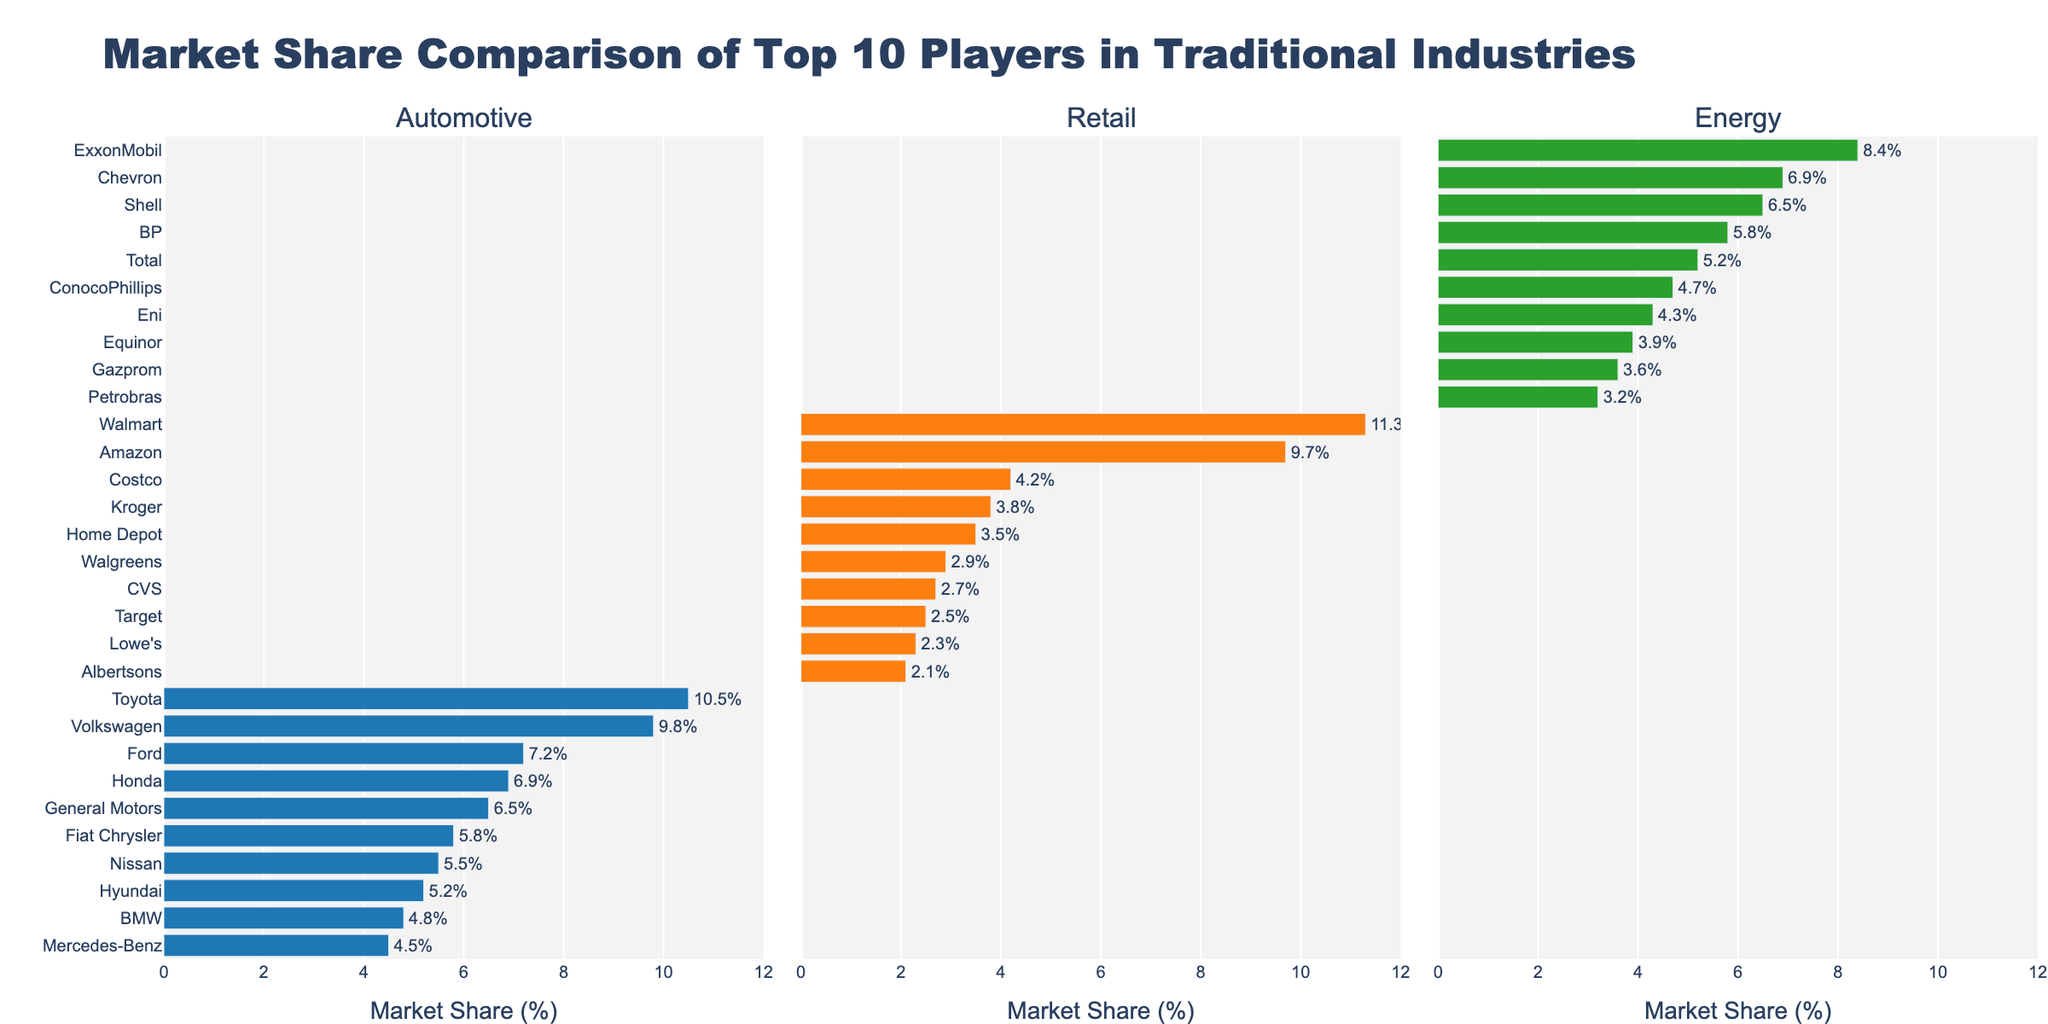Which automotive company has the highest market share? By looking at the "Automotive" subplot, identify the company with the longest bar. Toyota's bar is the longest, representing 10.5%.
Answer: Toyota Which retail company comes third in market share? Locate the "Retail" subplot and find the retail company with the third-longest bar. Costco occupies the third position with 4.2%.
Answer: Costco What is the combined market share of the top 3 companies in the energy sector? Identify the top 3 companies in the "Energy" subplot (ExxonMobil, Chevron, and Shell) and add their market shares: 8.4% + 6.9% + 6.5%.
Answer: 21.8% How much greater is Walmart's market share compared to Kroger's in the retail sector? Locate Walmart's and Kroger's market share in the "Retail" subplot (11.3% and 3.8%, respectively). Subtract Kroger's market share from Walmart's: 11.3% - 3.8%.
Answer: 7.5% Which company has the lowest market share in the automotive industry? Identify the company with the shortest bar in the "Automotive" subplot. Mercedes-Benz has the shortest bar at 4.5%.
Answer: Mercedes-Benz Between Amazon and Ford, which company has a higher market share and by how much? Identify Amazon's market share in the "Retail" subplot (9.7%) and Ford's in the "Automotive" subplot (7.2%). Subtract Ford's share from Amazon's share: 9.7% - 7.2%.
Answer: Amazon, 2.5% What is the average market share of the bottom 5 companies in the energy sector? Identify the bottom 5 companies in the "Energy" subplot (ConocoPhillips, Eni, Equinor, Gazprom, Petrobras) and calculate the average of their market shares: (4.7% + 4.3% + 3.9% + 3.6% + 3.2%) / 5.
Answer: 3.94% What is the difference in market share between the top automotive company and the top retail company? Identify the market shares of Toyota (10.5%) and Walmart (11.3%) from their respective subplots. Subtract Toyota's share from Walmart's: 11.3% - 10.5%.
Answer: 0.8% 